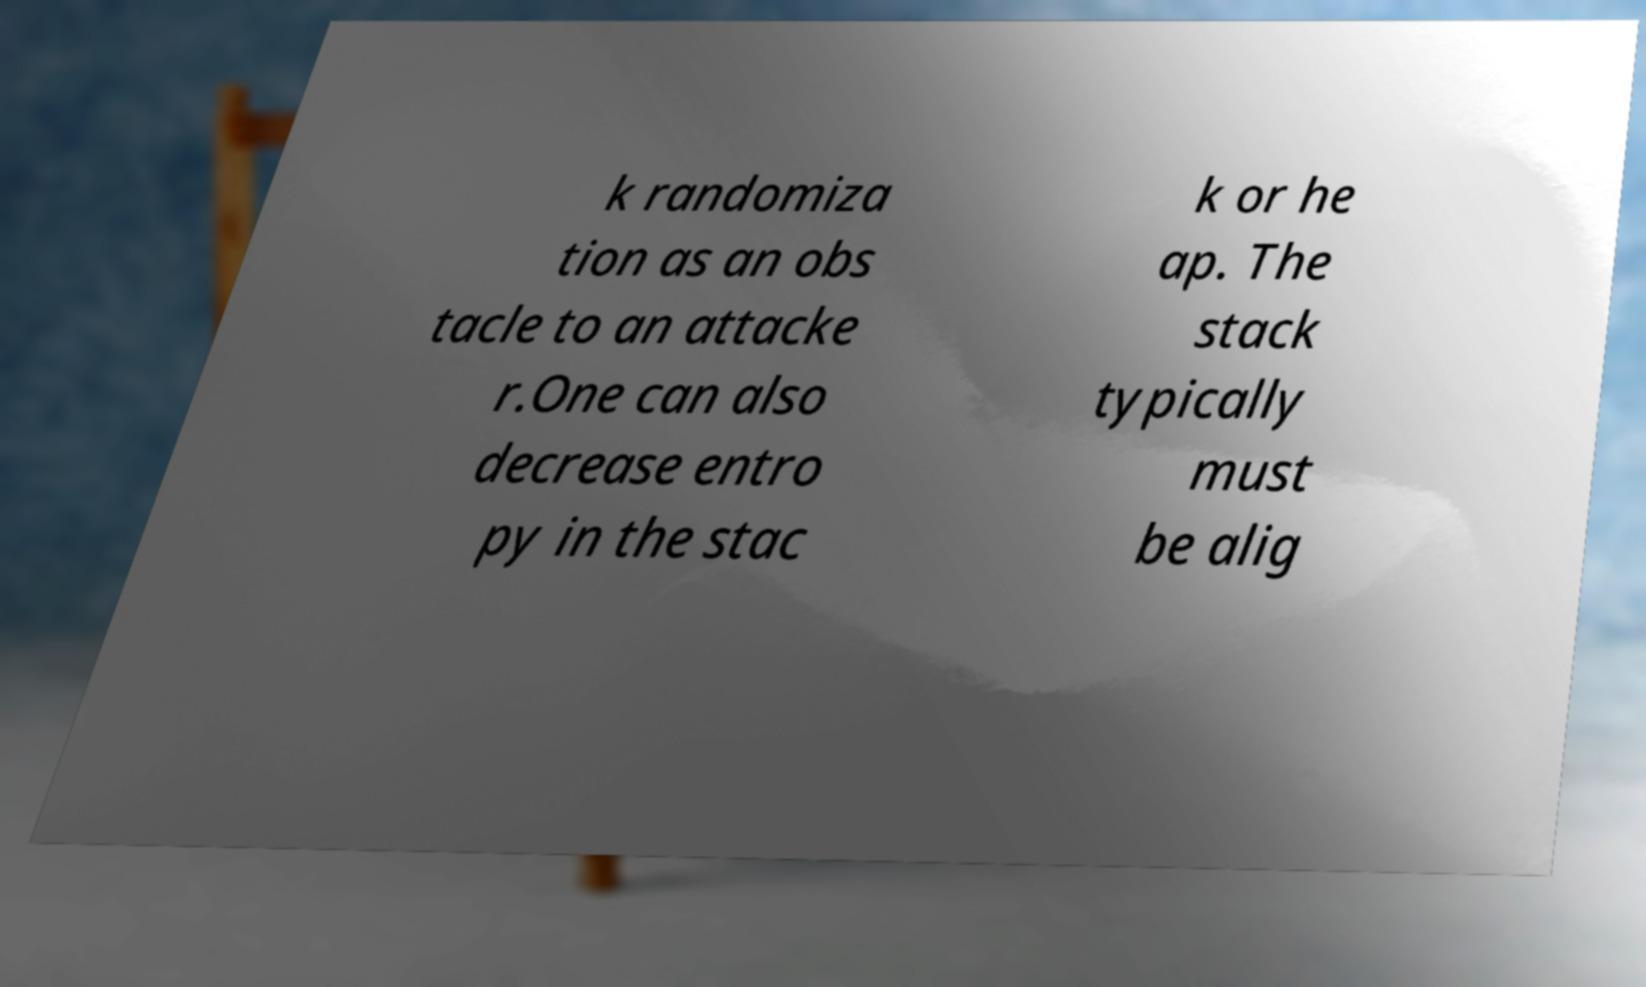Could you assist in decoding the text presented in this image and type it out clearly? k randomiza tion as an obs tacle to an attacke r.One can also decrease entro py in the stac k or he ap. The stack typically must be alig 